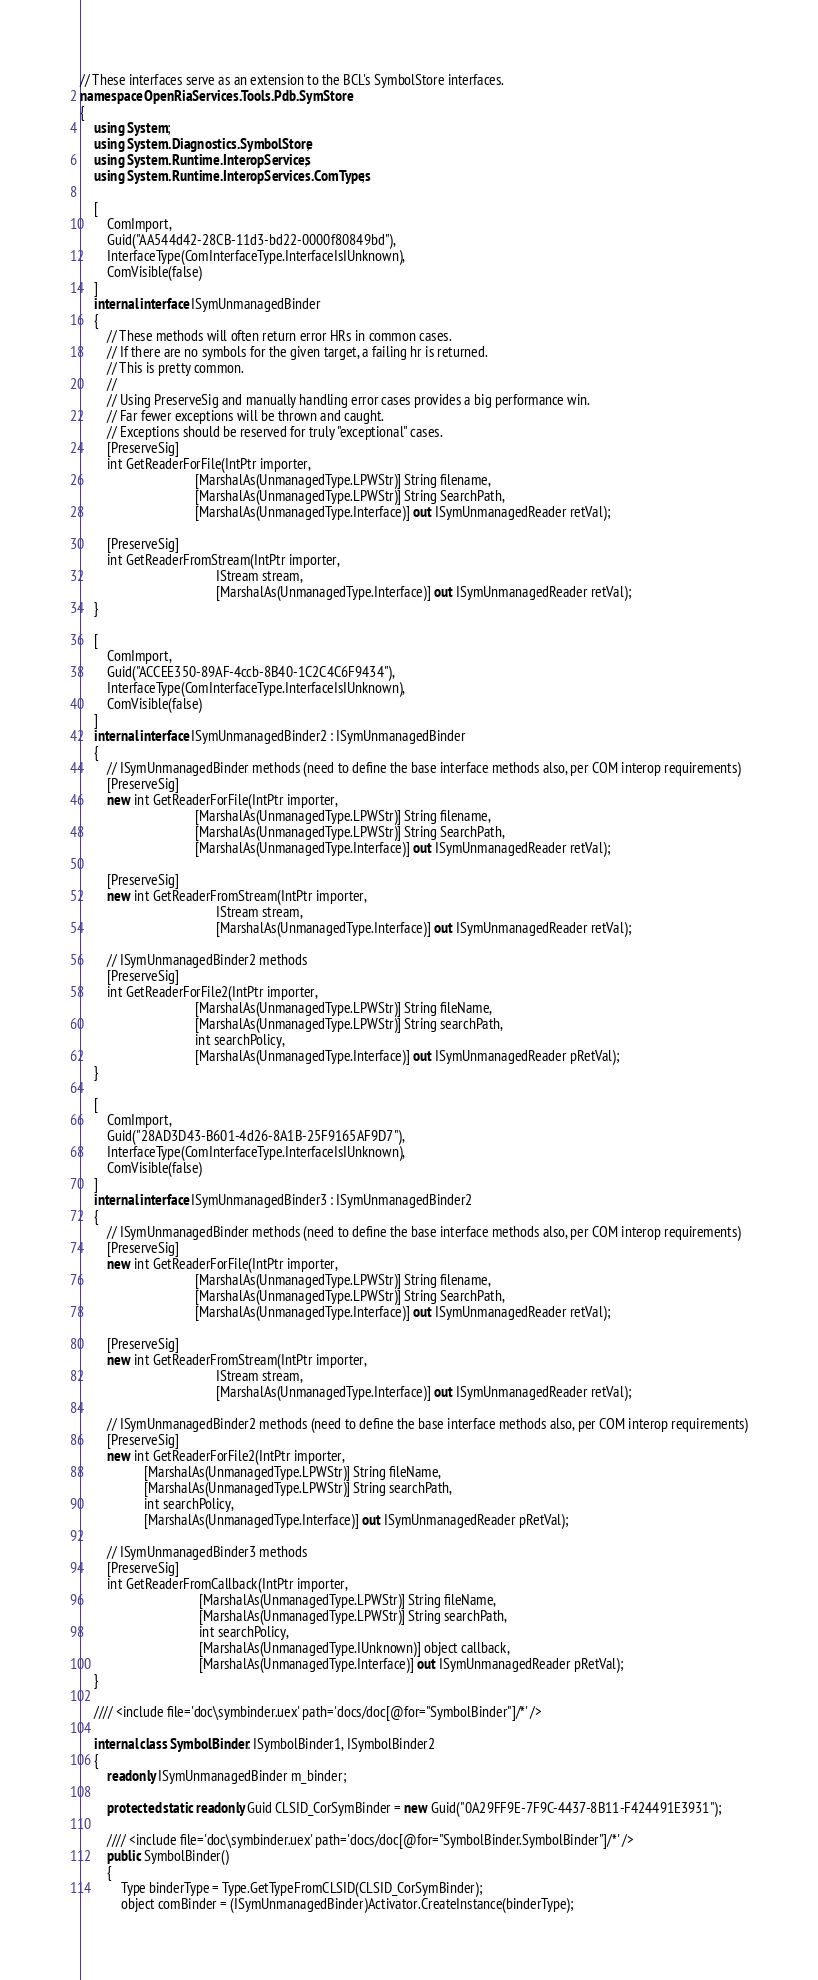<code> <loc_0><loc_0><loc_500><loc_500><_C#_>// These interfaces serve as an extension to the BCL's SymbolStore interfaces.
namespace OpenRiaServices.Tools.Pdb.SymStore 
{
    using System;
    using System.Diagnostics.SymbolStore;
    using System.Runtime.InteropServices;
    using System.Runtime.InteropServices.ComTypes;

    [
        ComImport,
        Guid("AA544d42-28CB-11d3-bd22-0000f80849bd"),
        InterfaceType(ComInterfaceType.InterfaceIsIUnknown),
        ComVisible(false)
    ]
    internal interface ISymUnmanagedBinder
    {
        // These methods will often return error HRs in common cases.
        // If there are no symbols for the given target, a failing hr is returned.
        // This is pretty common.
        //
        // Using PreserveSig and manually handling error cases provides a big performance win.
        // Far fewer exceptions will be thrown and caught.
        // Exceptions should be reserved for truly "exceptional" cases.
        [PreserveSig]
        int GetReaderForFile(IntPtr importer,
                                  [MarshalAs(UnmanagedType.LPWStr)] String filename,
                                  [MarshalAs(UnmanagedType.LPWStr)] String SearchPath,
                                  [MarshalAs(UnmanagedType.Interface)] out ISymUnmanagedReader retVal);

        [PreserveSig]
        int GetReaderFromStream(IntPtr importer,
                                        IStream stream,
                                        [MarshalAs(UnmanagedType.Interface)] out ISymUnmanagedReader retVal);
    }

    [
        ComImport,
        Guid("ACCEE350-89AF-4ccb-8B40-1C2C4C6F9434"),
        InterfaceType(ComInterfaceType.InterfaceIsIUnknown),
        ComVisible(false)
    ]
    internal interface ISymUnmanagedBinder2 : ISymUnmanagedBinder
    {
        // ISymUnmanagedBinder methods (need to define the base interface methods also, per COM interop requirements)
        [PreserveSig]
        new int GetReaderForFile(IntPtr importer,
                                  [MarshalAs(UnmanagedType.LPWStr)] String filename,
                                  [MarshalAs(UnmanagedType.LPWStr)] String SearchPath,
                                  [MarshalAs(UnmanagedType.Interface)] out ISymUnmanagedReader retVal);

        [PreserveSig]
        new int GetReaderFromStream(IntPtr importer,
                                        IStream stream,
                                        [MarshalAs(UnmanagedType.Interface)] out ISymUnmanagedReader retVal);

        // ISymUnmanagedBinder2 methods 
        [PreserveSig]
        int GetReaderForFile2(IntPtr importer,
                                  [MarshalAs(UnmanagedType.LPWStr)] String fileName,
                                  [MarshalAs(UnmanagedType.LPWStr)] String searchPath,
                                  int searchPolicy,
                                  [MarshalAs(UnmanagedType.Interface)] out ISymUnmanagedReader pRetVal);
    }
    
    [
        ComImport,
        Guid("28AD3D43-B601-4d26-8A1B-25F9165AF9D7"),
        InterfaceType(ComInterfaceType.InterfaceIsIUnknown),
        ComVisible(false)
    ]
    internal interface ISymUnmanagedBinder3 : ISymUnmanagedBinder2
    {
        // ISymUnmanagedBinder methods (need to define the base interface methods also, per COM interop requirements)
        [PreserveSig]
        new int GetReaderForFile(IntPtr importer,
                                  [MarshalAs(UnmanagedType.LPWStr)] String filename,
                                  [MarshalAs(UnmanagedType.LPWStr)] String SearchPath,
                                  [MarshalAs(UnmanagedType.Interface)] out ISymUnmanagedReader retVal);

        [PreserveSig]
        new int GetReaderFromStream(IntPtr importer,
                                        IStream stream,
                                        [MarshalAs(UnmanagedType.Interface)] out ISymUnmanagedReader retVal);

        // ISymUnmanagedBinder2 methods (need to define the base interface methods also, per COM interop requirements)
        [PreserveSig]
        new int GetReaderForFile2(IntPtr importer,
                   [MarshalAs(UnmanagedType.LPWStr)] String fileName,
                   [MarshalAs(UnmanagedType.LPWStr)] String searchPath,
                   int searchPolicy,
                   [MarshalAs(UnmanagedType.Interface)] out ISymUnmanagedReader pRetVal);

        // ISymUnmanagedBinder3 methods 
        [PreserveSig]
        int GetReaderFromCallback(IntPtr importer,
                                   [MarshalAs(UnmanagedType.LPWStr)] String fileName,
                                   [MarshalAs(UnmanagedType.LPWStr)] String searchPath,
                                   int searchPolicy,
                                   [MarshalAs(UnmanagedType.IUnknown)] object callback,
                                   [MarshalAs(UnmanagedType.Interface)] out ISymUnmanagedReader pRetVal);
    }

    //// <include file='doc\symbinder.uex' path='docs/doc[@for="SymbolBinder"]/*' />

    internal class SymbolBinder: ISymbolBinder1, ISymbolBinder2
    {
        readonly ISymUnmanagedBinder m_binder;

        protected static readonly Guid CLSID_CorSymBinder = new Guid("0A29FF9E-7F9C-4437-8B11-F424491E3931");

        //// <include file='doc\symbinder.uex' path='docs/doc[@for="SymbolBinder.SymbolBinder"]/*' />
        public SymbolBinder()
        {
            Type binderType = Type.GetTypeFromCLSID(CLSID_CorSymBinder);
            object comBinder = (ISymUnmanagedBinder)Activator.CreateInstance(binderType);</code> 